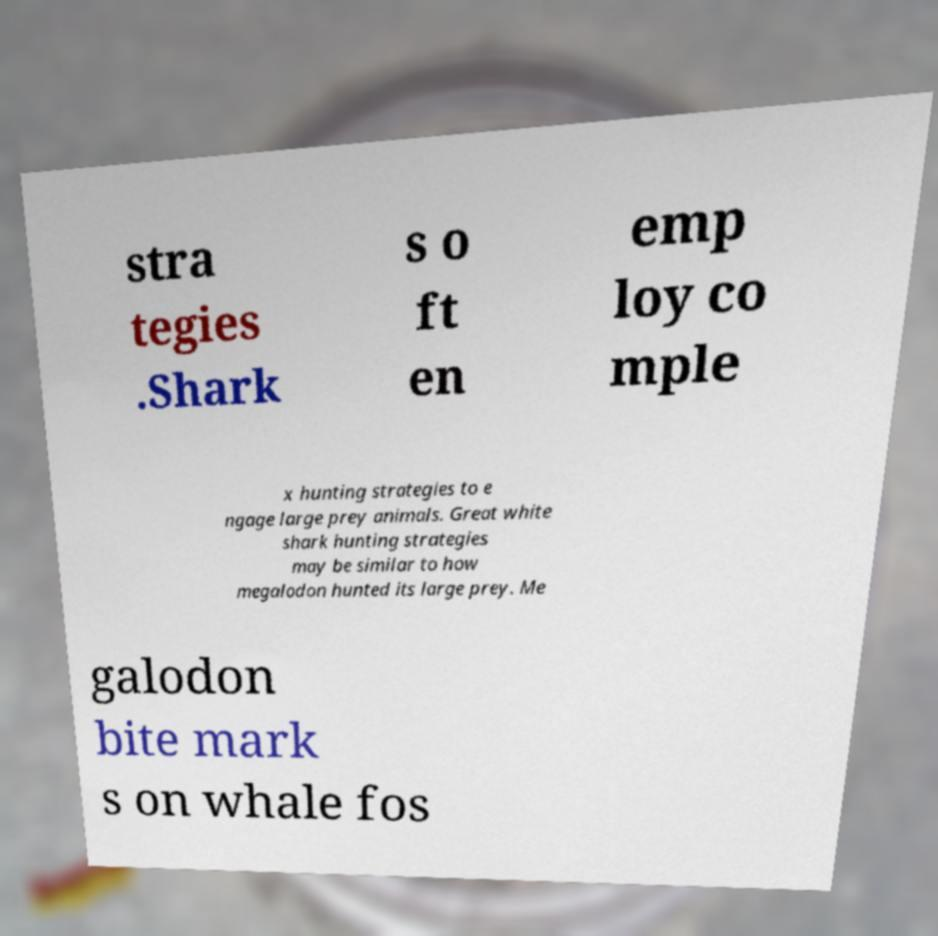Please identify and transcribe the text found in this image. stra tegies .Shark s o ft en emp loy co mple x hunting strategies to e ngage large prey animals. Great white shark hunting strategies may be similar to how megalodon hunted its large prey. Me galodon bite mark s on whale fos 